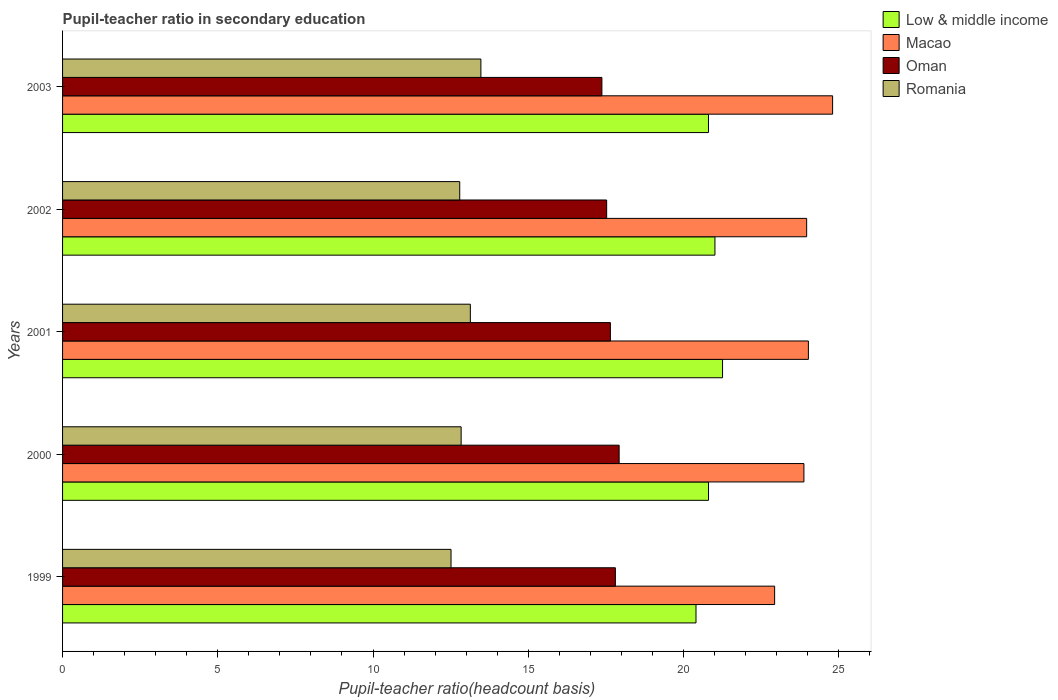How many different coloured bars are there?
Your response must be concise. 4. How many groups of bars are there?
Offer a terse response. 5. Are the number of bars on each tick of the Y-axis equal?
Give a very brief answer. Yes. How many bars are there on the 4th tick from the top?
Make the answer very short. 4. What is the label of the 2nd group of bars from the top?
Provide a short and direct response. 2002. What is the pupil-teacher ratio in secondary education in Romania in 2002?
Your answer should be compact. 12.79. Across all years, what is the maximum pupil-teacher ratio in secondary education in Oman?
Your response must be concise. 17.93. Across all years, what is the minimum pupil-teacher ratio in secondary education in Romania?
Provide a succinct answer. 12.51. In which year was the pupil-teacher ratio in secondary education in Macao minimum?
Make the answer very short. 1999. What is the total pupil-teacher ratio in secondary education in Romania in the graph?
Keep it short and to the point. 64.76. What is the difference between the pupil-teacher ratio in secondary education in Oman in 1999 and that in 2000?
Provide a succinct answer. -0.12. What is the difference between the pupil-teacher ratio in secondary education in Oman in 2001 and the pupil-teacher ratio in secondary education in Low & middle income in 2002?
Keep it short and to the point. -3.37. What is the average pupil-teacher ratio in secondary education in Low & middle income per year?
Provide a short and direct response. 20.86. In the year 2001, what is the difference between the pupil-teacher ratio in secondary education in Oman and pupil-teacher ratio in secondary education in Romania?
Give a very brief answer. 4.51. What is the ratio of the pupil-teacher ratio in secondary education in Romania in 2000 to that in 2001?
Make the answer very short. 0.98. Is the pupil-teacher ratio in secondary education in Oman in 2001 less than that in 2003?
Keep it short and to the point. No. What is the difference between the highest and the second highest pupil-teacher ratio in secondary education in Macao?
Provide a succinct answer. 0.78. What is the difference between the highest and the lowest pupil-teacher ratio in secondary education in Macao?
Offer a very short reply. 1.87. In how many years, is the pupil-teacher ratio in secondary education in Low & middle income greater than the average pupil-teacher ratio in secondary education in Low & middle income taken over all years?
Provide a succinct answer. 2. Is the sum of the pupil-teacher ratio in secondary education in Macao in 1999 and 2002 greater than the maximum pupil-teacher ratio in secondary education in Oman across all years?
Keep it short and to the point. Yes. Is it the case that in every year, the sum of the pupil-teacher ratio in secondary education in Romania and pupil-teacher ratio in secondary education in Oman is greater than the sum of pupil-teacher ratio in secondary education in Low & middle income and pupil-teacher ratio in secondary education in Macao?
Your answer should be compact. Yes. What does the 2nd bar from the bottom in 1999 represents?
Make the answer very short. Macao. Are all the bars in the graph horizontal?
Make the answer very short. Yes. What is the difference between two consecutive major ticks on the X-axis?
Provide a short and direct response. 5. Are the values on the major ticks of X-axis written in scientific E-notation?
Ensure brevity in your answer.  No. How are the legend labels stacked?
Provide a short and direct response. Vertical. What is the title of the graph?
Offer a terse response. Pupil-teacher ratio in secondary education. Does "Luxembourg" appear as one of the legend labels in the graph?
Make the answer very short. No. What is the label or title of the X-axis?
Your response must be concise. Pupil-teacher ratio(headcount basis). What is the label or title of the Y-axis?
Provide a succinct answer. Years. What is the Pupil-teacher ratio(headcount basis) in Low & middle income in 1999?
Ensure brevity in your answer.  20.4. What is the Pupil-teacher ratio(headcount basis) of Macao in 1999?
Ensure brevity in your answer.  22.94. What is the Pupil-teacher ratio(headcount basis) of Oman in 1999?
Your answer should be compact. 17.81. What is the Pupil-teacher ratio(headcount basis) of Romania in 1999?
Offer a terse response. 12.51. What is the Pupil-teacher ratio(headcount basis) in Low & middle income in 2000?
Keep it short and to the point. 20.81. What is the Pupil-teacher ratio(headcount basis) in Macao in 2000?
Your response must be concise. 23.88. What is the Pupil-teacher ratio(headcount basis) in Oman in 2000?
Provide a short and direct response. 17.93. What is the Pupil-teacher ratio(headcount basis) in Romania in 2000?
Provide a succinct answer. 12.84. What is the Pupil-teacher ratio(headcount basis) in Low & middle income in 2001?
Keep it short and to the point. 21.26. What is the Pupil-teacher ratio(headcount basis) of Macao in 2001?
Provide a succinct answer. 24.02. What is the Pupil-teacher ratio(headcount basis) in Oman in 2001?
Give a very brief answer. 17.65. What is the Pupil-teacher ratio(headcount basis) in Romania in 2001?
Your answer should be very brief. 13.14. What is the Pupil-teacher ratio(headcount basis) in Low & middle income in 2002?
Provide a short and direct response. 21.01. What is the Pupil-teacher ratio(headcount basis) in Macao in 2002?
Make the answer very short. 23.97. What is the Pupil-teacher ratio(headcount basis) of Oman in 2002?
Make the answer very short. 17.53. What is the Pupil-teacher ratio(headcount basis) of Romania in 2002?
Provide a succinct answer. 12.79. What is the Pupil-teacher ratio(headcount basis) of Low & middle income in 2003?
Your answer should be compact. 20.81. What is the Pupil-teacher ratio(headcount basis) of Macao in 2003?
Ensure brevity in your answer.  24.8. What is the Pupil-teacher ratio(headcount basis) of Oman in 2003?
Your answer should be very brief. 17.37. What is the Pupil-teacher ratio(headcount basis) in Romania in 2003?
Make the answer very short. 13.47. Across all years, what is the maximum Pupil-teacher ratio(headcount basis) of Low & middle income?
Offer a very short reply. 21.26. Across all years, what is the maximum Pupil-teacher ratio(headcount basis) of Macao?
Provide a succinct answer. 24.8. Across all years, what is the maximum Pupil-teacher ratio(headcount basis) in Oman?
Ensure brevity in your answer.  17.93. Across all years, what is the maximum Pupil-teacher ratio(headcount basis) of Romania?
Make the answer very short. 13.47. Across all years, what is the minimum Pupil-teacher ratio(headcount basis) of Low & middle income?
Provide a short and direct response. 20.4. Across all years, what is the minimum Pupil-teacher ratio(headcount basis) in Macao?
Offer a terse response. 22.94. Across all years, what is the minimum Pupil-teacher ratio(headcount basis) of Oman?
Provide a short and direct response. 17.37. Across all years, what is the minimum Pupil-teacher ratio(headcount basis) in Romania?
Offer a very short reply. 12.51. What is the total Pupil-teacher ratio(headcount basis) in Low & middle income in the graph?
Offer a very short reply. 104.29. What is the total Pupil-teacher ratio(headcount basis) of Macao in the graph?
Provide a short and direct response. 119.61. What is the total Pupil-teacher ratio(headcount basis) of Oman in the graph?
Offer a very short reply. 88.28. What is the total Pupil-teacher ratio(headcount basis) of Romania in the graph?
Your answer should be very brief. 64.76. What is the difference between the Pupil-teacher ratio(headcount basis) in Low & middle income in 1999 and that in 2000?
Offer a very short reply. -0.4. What is the difference between the Pupil-teacher ratio(headcount basis) in Macao in 1999 and that in 2000?
Your answer should be very brief. -0.94. What is the difference between the Pupil-teacher ratio(headcount basis) in Oman in 1999 and that in 2000?
Provide a succinct answer. -0.12. What is the difference between the Pupil-teacher ratio(headcount basis) of Romania in 1999 and that in 2000?
Provide a short and direct response. -0.33. What is the difference between the Pupil-teacher ratio(headcount basis) of Low & middle income in 1999 and that in 2001?
Your answer should be compact. -0.85. What is the difference between the Pupil-teacher ratio(headcount basis) of Macao in 1999 and that in 2001?
Your answer should be very brief. -1.09. What is the difference between the Pupil-teacher ratio(headcount basis) of Oman in 1999 and that in 2001?
Keep it short and to the point. 0.16. What is the difference between the Pupil-teacher ratio(headcount basis) in Romania in 1999 and that in 2001?
Your response must be concise. -0.62. What is the difference between the Pupil-teacher ratio(headcount basis) of Low & middle income in 1999 and that in 2002?
Provide a succinct answer. -0.61. What is the difference between the Pupil-teacher ratio(headcount basis) in Macao in 1999 and that in 2002?
Your answer should be very brief. -1.03. What is the difference between the Pupil-teacher ratio(headcount basis) in Oman in 1999 and that in 2002?
Give a very brief answer. 0.28. What is the difference between the Pupil-teacher ratio(headcount basis) of Romania in 1999 and that in 2002?
Provide a succinct answer. -0.28. What is the difference between the Pupil-teacher ratio(headcount basis) in Low & middle income in 1999 and that in 2003?
Your answer should be compact. -0.4. What is the difference between the Pupil-teacher ratio(headcount basis) in Macao in 1999 and that in 2003?
Offer a very short reply. -1.87. What is the difference between the Pupil-teacher ratio(headcount basis) in Oman in 1999 and that in 2003?
Provide a short and direct response. 0.43. What is the difference between the Pupil-teacher ratio(headcount basis) of Romania in 1999 and that in 2003?
Your response must be concise. -0.96. What is the difference between the Pupil-teacher ratio(headcount basis) of Low & middle income in 2000 and that in 2001?
Provide a succinct answer. -0.45. What is the difference between the Pupil-teacher ratio(headcount basis) in Macao in 2000 and that in 2001?
Make the answer very short. -0.14. What is the difference between the Pupil-teacher ratio(headcount basis) in Oman in 2000 and that in 2001?
Give a very brief answer. 0.28. What is the difference between the Pupil-teacher ratio(headcount basis) of Romania in 2000 and that in 2001?
Your response must be concise. -0.3. What is the difference between the Pupil-teacher ratio(headcount basis) in Low & middle income in 2000 and that in 2002?
Your answer should be compact. -0.21. What is the difference between the Pupil-teacher ratio(headcount basis) in Macao in 2000 and that in 2002?
Provide a succinct answer. -0.09. What is the difference between the Pupil-teacher ratio(headcount basis) of Oman in 2000 and that in 2002?
Ensure brevity in your answer.  0.4. What is the difference between the Pupil-teacher ratio(headcount basis) of Romania in 2000 and that in 2002?
Your answer should be compact. 0.04. What is the difference between the Pupil-teacher ratio(headcount basis) in Low & middle income in 2000 and that in 2003?
Provide a succinct answer. 0. What is the difference between the Pupil-teacher ratio(headcount basis) in Macao in 2000 and that in 2003?
Provide a succinct answer. -0.92. What is the difference between the Pupil-teacher ratio(headcount basis) in Oman in 2000 and that in 2003?
Your answer should be compact. 0.56. What is the difference between the Pupil-teacher ratio(headcount basis) in Romania in 2000 and that in 2003?
Make the answer very short. -0.64. What is the difference between the Pupil-teacher ratio(headcount basis) of Low & middle income in 2001 and that in 2002?
Ensure brevity in your answer.  0.25. What is the difference between the Pupil-teacher ratio(headcount basis) in Macao in 2001 and that in 2002?
Make the answer very short. 0.06. What is the difference between the Pupil-teacher ratio(headcount basis) of Oman in 2001 and that in 2002?
Keep it short and to the point. 0.12. What is the difference between the Pupil-teacher ratio(headcount basis) of Romania in 2001 and that in 2002?
Offer a very short reply. 0.34. What is the difference between the Pupil-teacher ratio(headcount basis) in Low & middle income in 2001 and that in 2003?
Offer a terse response. 0.45. What is the difference between the Pupil-teacher ratio(headcount basis) in Macao in 2001 and that in 2003?
Your answer should be very brief. -0.78. What is the difference between the Pupil-teacher ratio(headcount basis) in Oman in 2001 and that in 2003?
Provide a short and direct response. 0.27. What is the difference between the Pupil-teacher ratio(headcount basis) of Romania in 2001 and that in 2003?
Offer a very short reply. -0.34. What is the difference between the Pupil-teacher ratio(headcount basis) of Low & middle income in 2002 and that in 2003?
Keep it short and to the point. 0.21. What is the difference between the Pupil-teacher ratio(headcount basis) of Macao in 2002 and that in 2003?
Your response must be concise. -0.84. What is the difference between the Pupil-teacher ratio(headcount basis) of Oman in 2002 and that in 2003?
Keep it short and to the point. 0.15. What is the difference between the Pupil-teacher ratio(headcount basis) of Romania in 2002 and that in 2003?
Provide a succinct answer. -0.68. What is the difference between the Pupil-teacher ratio(headcount basis) of Low & middle income in 1999 and the Pupil-teacher ratio(headcount basis) of Macao in 2000?
Offer a terse response. -3.48. What is the difference between the Pupil-teacher ratio(headcount basis) in Low & middle income in 1999 and the Pupil-teacher ratio(headcount basis) in Oman in 2000?
Offer a terse response. 2.48. What is the difference between the Pupil-teacher ratio(headcount basis) in Low & middle income in 1999 and the Pupil-teacher ratio(headcount basis) in Romania in 2000?
Ensure brevity in your answer.  7.57. What is the difference between the Pupil-teacher ratio(headcount basis) in Macao in 1999 and the Pupil-teacher ratio(headcount basis) in Oman in 2000?
Make the answer very short. 5.01. What is the difference between the Pupil-teacher ratio(headcount basis) in Macao in 1999 and the Pupil-teacher ratio(headcount basis) in Romania in 2000?
Offer a very short reply. 10.1. What is the difference between the Pupil-teacher ratio(headcount basis) of Oman in 1999 and the Pupil-teacher ratio(headcount basis) of Romania in 2000?
Ensure brevity in your answer.  4.97. What is the difference between the Pupil-teacher ratio(headcount basis) in Low & middle income in 1999 and the Pupil-teacher ratio(headcount basis) in Macao in 2001?
Provide a succinct answer. -3.62. What is the difference between the Pupil-teacher ratio(headcount basis) in Low & middle income in 1999 and the Pupil-teacher ratio(headcount basis) in Oman in 2001?
Your answer should be compact. 2.76. What is the difference between the Pupil-teacher ratio(headcount basis) in Low & middle income in 1999 and the Pupil-teacher ratio(headcount basis) in Romania in 2001?
Your answer should be compact. 7.27. What is the difference between the Pupil-teacher ratio(headcount basis) in Macao in 1999 and the Pupil-teacher ratio(headcount basis) in Oman in 2001?
Your answer should be very brief. 5.29. What is the difference between the Pupil-teacher ratio(headcount basis) in Macao in 1999 and the Pupil-teacher ratio(headcount basis) in Romania in 2001?
Your response must be concise. 9.8. What is the difference between the Pupil-teacher ratio(headcount basis) of Oman in 1999 and the Pupil-teacher ratio(headcount basis) of Romania in 2001?
Offer a very short reply. 4.67. What is the difference between the Pupil-teacher ratio(headcount basis) in Low & middle income in 1999 and the Pupil-teacher ratio(headcount basis) in Macao in 2002?
Your answer should be compact. -3.56. What is the difference between the Pupil-teacher ratio(headcount basis) in Low & middle income in 1999 and the Pupil-teacher ratio(headcount basis) in Oman in 2002?
Your answer should be very brief. 2.88. What is the difference between the Pupil-teacher ratio(headcount basis) of Low & middle income in 1999 and the Pupil-teacher ratio(headcount basis) of Romania in 2002?
Provide a short and direct response. 7.61. What is the difference between the Pupil-teacher ratio(headcount basis) of Macao in 1999 and the Pupil-teacher ratio(headcount basis) of Oman in 2002?
Offer a terse response. 5.41. What is the difference between the Pupil-teacher ratio(headcount basis) in Macao in 1999 and the Pupil-teacher ratio(headcount basis) in Romania in 2002?
Your answer should be compact. 10.14. What is the difference between the Pupil-teacher ratio(headcount basis) in Oman in 1999 and the Pupil-teacher ratio(headcount basis) in Romania in 2002?
Give a very brief answer. 5.01. What is the difference between the Pupil-teacher ratio(headcount basis) in Low & middle income in 1999 and the Pupil-teacher ratio(headcount basis) in Macao in 2003?
Make the answer very short. -4.4. What is the difference between the Pupil-teacher ratio(headcount basis) in Low & middle income in 1999 and the Pupil-teacher ratio(headcount basis) in Oman in 2003?
Make the answer very short. 3.03. What is the difference between the Pupil-teacher ratio(headcount basis) in Low & middle income in 1999 and the Pupil-teacher ratio(headcount basis) in Romania in 2003?
Your response must be concise. 6.93. What is the difference between the Pupil-teacher ratio(headcount basis) of Macao in 1999 and the Pupil-teacher ratio(headcount basis) of Oman in 2003?
Give a very brief answer. 5.56. What is the difference between the Pupil-teacher ratio(headcount basis) in Macao in 1999 and the Pupil-teacher ratio(headcount basis) in Romania in 2003?
Give a very brief answer. 9.46. What is the difference between the Pupil-teacher ratio(headcount basis) in Oman in 1999 and the Pupil-teacher ratio(headcount basis) in Romania in 2003?
Give a very brief answer. 4.33. What is the difference between the Pupil-teacher ratio(headcount basis) of Low & middle income in 2000 and the Pupil-teacher ratio(headcount basis) of Macao in 2001?
Provide a succinct answer. -3.22. What is the difference between the Pupil-teacher ratio(headcount basis) of Low & middle income in 2000 and the Pupil-teacher ratio(headcount basis) of Oman in 2001?
Your answer should be compact. 3.16. What is the difference between the Pupil-teacher ratio(headcount basis) of Low & middle income in 2000 and the Pupil-teacher ratio(headcount basis) of Romania in 2001?
Ensure brevity in your answer.  7.67. What is the difference between the Pupil-teacher ratio(headcount basis) of Macao in 2000 and the Pupil-teacher ratio(headcount basis) of Oman in 2001?
Your answer should be compact. 6.23. What is the difference between the Pupil-teacher ratio(headcount basis) in Macao in 2000 and the Pupil-teacher ratio(headcount basis) in Romania in 2001?
Provide a short and direct response. 10.75. What is the difference between the Pupil-teacher ratio(headcount basis) in Oman in 2000 and the Pupil-teacher ratio(headcount basis) in Romania in 2001?
Your answer should be very brief. 4.79. What is the difference between the Pupil-teacher ratio(headcount basis) in Low & middle income in 2000 and the Pupil-teacher ratio(headcount basis) in Macao in 2002?
Provide a short and direct response. -3.16. What is the difference between the Pupil-teacher ratio(headcount basis) in Low & middle income in 2000 and the Pupil-teacher ratio(headcount basis) in Oman in 2002?
Provide a short and direct response. 3.28. What is the difference between the Pupil-teacher ratio(headcount basis) of Low & middle income in 2000 and the Pupil-teacher ratio(headcount basis) of Romania in 2002?
Your answer should be compact. 8.01. What is the difference between the Pupil-teacher ratio(headcount basis) in Macao in 2000 and the Pupil-teacher ratio(headcount basis) in Oman in 2002?
Offer a terse response. 6.35. What is the difference between the Pupil-teacher ratio(headcount basis) of Macao in 2000 and the Pupil-teacher ratio(headcount basis) of Romania in 2002?
Make the answer very short. 11.09. What is the difference between the Pupil-teacher ratio(headcount basis) of Oman in 2000 and the Pupil-teacher ratio(headcount basis) of Romania in 2002?
Your response must be concise. 5.13. What is the difference between the Pupil-teacher ratio(headcount basis) of Low & middle income in 2000 and the Pupil-teacher ratio(headcount basis) of Macao in 2003?
Provide a succinct answer. -4. What is the difference between the Pupil-teacher ratio(headcount basis) in Low & middle income in 2000 and the Pupil-teacher ratio(headcount basis) in Oman in 2003?
Ensure brevity in your answer.  3.43. What is the difference between the Pupil-teacher ratio(headcount basis) in Low & middle income in 2000 and the Pupil-teacher ratio(headcount basis) in Romania in 2003?
Your response must be concise. 7.33. What is the difference between the Pupil-teacher ratio(headcount basis) of Macao in 2000 and the Pupil-teacher ratio(headcount basis) of Oman in 2003?
Provide a short and direct response. 6.51. What is the difference between the Pupil-teacher ratio(headcount basis) of Macao in 2000 and the Pupil-teacher ratio(headcount basis) of Romania in 2003?
Ensure brevity in your answer.  10.41. What is the difference between the Pupil-teacher ratio(headcount basis) of Oman in 2000 and the Pupil-teacher ratio(headcount basis) of Romania in 2003?
Make the answer very short. 4.45. What is the difference between the Pupil-teacher ratio(headcount basis) of Low & middle income in 2001 and the Pupil-teacher ratio(headcount basis) of Macao in 2002?
Your answer should be very brief. -2.71. What is the difference between the Pupil-teacher ratio(headcount basis) in Low & middle income in 2001 and the Pupil-teacher ratio(headcount basis) in Oman in 2002?
Your answer should be compact. 3.73. What is the difference between the Pupil-teacher ratio(headcount basis) in Low & middle income in 2001 and the Pupil-teacher ratio(headcount basis) in Romania in 2002?
Your answer should be very brief. 8.47. What is the difference between the Pupil-teacher ratio(headcount basis) of Macao in 2001 and the Pupil-teacher ratio(headcount basis) of Oman in 2002?
Your response must be concise. 6.5. What is the difference between the Pupil-teacher ratio(headcount basis) of Macao in 2001 and the Pupil-teacher ratio(headcount basis) of Romania in 2002?
Ensure brevity in your answer.  11.23. What is the difference between the Pupil-teacher ratio(headcount basis) of Oman in 2001 and the Pupil-teacher ratio(headcount basis) of Romania in 2002?
Provide a short and direct response. 4.85. What is the difference between the Pupil-teacher ratio(headcount basis) of Low & middle income in 2001 and the Pupil-teacher ratio(headcount basis) of Macao in 2003?
Offer a terse response. -3.55. What is the difference between the Pupil-teacher ratio(headcount basis) in Low & middle income in 2001 and the Pupil-teacher ratio(headcount basis) in Oman in 2003?
Provide a succinct answer. 3.89. What is the difference between the Pupil-teacher ratio(headcount basis) of Low & middle income in 2001 and the Pupil-teacher ratio(headcount basis) of Romania in 2003?
Your response must be concise. 7.78. What is the difference between the Pupil-teacher ratio(headcount basis) of Macao in 2001 and the Pupil-teacher ratio(headcount basis) of Oman in 2003?
Give a very brief answer. 6.65. What is the difference between the Pupil-teacher ratio(headcount basis) of Macao in 2001 and the Pupil-teacher ratio(headcount basis) of Romania in 2003?
Keep it short and to the point. 10.55. What is the difference between the Pupil-teacher ratio(headcount basis) in Oman in 2001 and the Pupil-teacher ratio(headcount basis) in Romania in 2003?
Your answer should be compact. 4.17. What is the difference between the Pupil-teacher ratio(headcount basis) of Low & middle income in 2002 and the Pupil-teacher ratio(headcount basis) of Macao in 2003?
Provide a succinct answer. -3.79. What is the difference between the Pupil-teacher ratio(headcount basis) in Low & middle income in 2002 and the Pupil-teacher ratio(headcount basis) in Oman in 2003?
Your answer should be very brief. 3.64. What is the difference between the Pupil-teacher ratio(headcount basis) in Low & middle income in 2002 and the Pupil-teacher ratio(headcount basis) in Romania in 2003?
Ensure brevity in your answer.  7.54. What is the difference between the Pupil-teacher ratio(headcount basis) in Macao in 2002 and the Pupil-teacher ratio(headcount basis) in Oman in 2003?
Your answer should be compact. 6.6. What is the difference between the Pupil-teacher ratio(headcount basis) in Macao in 2002 and the Pupil-teacher ratio(headcount basis) in Romania in 2003?
Make the answer very short. 10.49. What is the difference between the Pupil-teacher ratio(headcount basis) in Oman in 2002 and the Pupil-teacher ratio(headcount basis) in Romania in 2003?
Your response must be concise. 4.05. What is the average Pupil-teacher ratio(headcount basis) of Low & middle income per year?
Provide a short and direct response. 20.86. What is the average Pupil-teacher ratio(headcount basis) of Macao per year?
Your response must be concise. 23.92. What is the average Pupil-teacher ratio(headcount basis) of Oman per year?
Offer a very short reply. 17.66. What is the average Pupil-teacher ratio(headcount basis) in Romania per year?
Make the answer very short. 12.95. In the year 1999, what is the difference between the Pupil-teacher ratio(headcount basis) of Low & middle income and Pupil-teacher ratio(headcount basis) of Macao?
Keep it short and to the point. -2.53. In the year 1999, what is the difference between the Pupil-teacher ratio(headcount basis) of Low & middle income and Pupil-teacher ratio(headcount basis) of Oman?
Your answer should be very brief. 2.6. In the year 1999, what is the difference between the Pupil-teacher ratio(headcount basis) in Low & middle income and Pupil-teacher ratio(headcount basis) in Romania?
Provide a succinct answer. 7.89. In the year 1999, what is the difference between the Pupil-teacher ratio(headcount basis) of Macao and Pupil-teacher ratio(headcount basis) of Oman?
Provide a succinct answer. 5.13. In the year 1999, what is the difference between the Pupil-teacher ratio(headcount basis) of Macao and Pupil-teacher ratio(headcount basis) of Romania?
Your answer should be very brief. 10.42. In the year 1999, what is the difference between the Pupil-teacher ratio(headcount basis) of Oman and Pupil-teacher ratio(headcount basis) of Romania?
Provide a short and direct response. 5.29. In the year 2000, what is the difference between the Pupil-teacher ratio(headcount basis) in Low & middle income and Pupil-teacher ratio(headcount basis) in Macao?
Give a very brief answer. -3.07. In the year 2000, what is the difference between the Pupil-teacher ratio(headcount basis) in Low & middle income and Pupil-teacher ratio(headcount basis) in Oman?
Make the answer very short. 2.88. In the year 2000, what is the difference between the Pupil-teacher ratio(headcount basis) of Low & middle income and Pupil-teacher ratio(headcount basis) of Romania?
Offer a very short reply. 7.97. In the year 2000, what is the difference between the Pupil-teacher ratio(headcount basis) in Macao and Pupil-teacher ratio(headcount basis) in Oman?
Keep it short and to the point. 5.95. In the year 2000, what is the difference between the Pupil-teacher ratio(headcount basis) in Macao and Pupil-teacher ratio(headcount basis) in Romania?
Keep it short and to the point. 11.04. In the year 2000, what is the difference between the Pupil-teacher ratio(headcount basis) in Oman and Pupil-teacher ratio(headcount basis) in Romania?
Provide a succinct answer. 5.09. In the year 2001, what is the difference between the Pupil-teacher ratio(headcount basis) of Low & middle income and Pupil-teacher ratio(headcount basis) of Macao?
Give a very brief answer. -2.77. In the year 2001, what is the difference between the Pupil-teacher ratio(headcount basis) in Low & middle income and Pupil-teacher ratio(headcount basis) in Oman?
Your response must be concise. 3.61. In the year 2001, what is the difference between the Pupil-teacher ratio(headcount basis) of Low & middle income and Pupil-teacher ratio(headcount basis) of Romania?
Ensure brevity in your answer.  8.12. In the year 2001, what is the difference between the Pupil-teacher ratio(headcount basis) in Macao and Pupil-teacher ratio(headcount basis) in Oman?
Offer a terse response. 6.38. In the year 2001, what is the difference between the Pupil-teacher ratio(headcount basis) of Macao and Pupil-teacher ratio(headcount basis) of Romania?
Provide a short and direct response. 10.89. In the year 2001, what is the difference between the Pupil-teacher ratio(headcount basis) of Oman and Pupil-teacher ratio(headcount basis) of Romania?
Make the answer very short. 4.51. In the year 2002, what is the difference between the Pupil-teacher ratio(headcount basis) of Low & middle income and Pupil-teacher ratio(headcount basis) of Macao?
Make the answer very short. -2.95. In the year 2002, what is the difference between the Pupil-teacher ratio(headcount basis) of Low & middle income and Pupil-teacher ratio(headcount basis) of Oman?
Provide a short and direct response. 3.49. In the year 2002, what is the difference between the Pupil-teacher ratio(headcount basis) of Low & middle income and Pupil-teacher ratio(headcount basis) of Romania?
Provide a short and direct response. 8.22. In the year 2002, what is the difference between the Pupil-teacher ratio(headcount basis) in Macao and Pupil-teacher ratio(headcount basis) in Oman?
Provide a succinct answer. 6.44. In the year 2002, what is the difference between the Pupil-teacher ratio(headcount basis) of Macao and Pupil-teacher ratio(headcount basis) of Romania?
Ensure brevity in your answer.  11.17. In the year 2002, what is the difference between the Pupil-teacher ratio(headcount basis) of Oman and Pupil-teacher ratio(headcount basis) of Romania?
Your answer should be compact. 4.73. In the year 2003, what is the difference between the Pupil-teacher ratio(headcount basis) in Low & middle income and Pupil-teacher ratio(headcount basis) in Macao?
Ensure brevity in your answer.  -4. In the year 2003, what is the difference between the Pupil-teacher ratio(headcount basis) in Low & middle income and Pupil-teacher ratio(headcount basis) in Oman?
Make the answer very short. 3.43. In the year 2003, what is the difference between the Pupil-teacher ratio(headcount basis) in Low & middle income and Pupil-teacher ratio(headcount basis) in Romania?
Give a very brief answer. 7.33. In the year 2003, what is the difference between the Pupil-teacher ratio(headcount basis) of Macao and Pupil-teacher ratio(headcount basis) of Oman?
Make the answer very short. 7.43. In the year 2003, what is the difference between the Pupil-teacher ratio(headcount basis) of Macao and Pupil-teacher ratio(headcount basis) of Romania?
Ensure brevity in your answer.  11.33. In the year 2003, what is the difference between the Pupil-teacher ratio(headcount basis) of Oman and Pupil-teacher ratio(headcount basis) of Romania?
Offer a very short reply. 3.9. What is the ratio of the Pupil-teacher ratio(headcount basis) in Low & middle income in 1999 to that in 2000?
Make the answer very short. 0.98. What is the ratio of the Pupil-teacher ratio(headcount basis) in Macao in 1999 to that in 2000?
Make the answer very short. 0.96. What is the ratio of the Pupil-teacher ratio(headcount basis) in Oman in 1999 to that in 2000?
Provide a short and direct response. 0.99. What is the ratio of the Pupil-teacher ratio(headcount basis) of Romania in 1999 to that in 2000?
Your answer should be compact. 0.97. What is the ratio of the Pupil-teacher ratio(headcount basis) of Low & middle income in 1999 to that in 2001?
Offer a very short reply. 0.96. What is the ratio of the Pupil-teacher ratio(headcount basis) in Macao in 1999 to that in 2001?
Your response must be concise. 0.95. What is the ratio of the Pupil-teacher ratio(headcount basis) of Oman in 1999 to that in 2001?
Provide a short and direct response. 1.01. What is the ratio of the Pupil-teacher ratio(headcount basis) in Romania in 1999 to that in 2001?
Provide a succinct answer. 0.95. What is the ratio of the Pupil-teacher ratio(headcount basis) in Low & middle income in 1999 to that in 2002?
Give a very brief answer. 0.97. What is the ratio of the Pupil-teacher ratio(headcount basis) of Macao in 1999 to that in 2002?
Offer a very short reply. 0.96. What is the ratio of the Pupil-teacher ratio(headcount basis) in Romania in 1999 to that in 2002?
Ensure brevity in your answer.  0.98. What is the ratio of the Pupil-teacher ratio(headcount basis) of Low & middle income in 1999 to that in 2003?
Your response must be concise. 0.98. What is the ratio of the Pupil-teacher ratio(headcount basis) of Macao in 1999 to that in 2003?
Keep it short and to the point. 0.92. What is the ratio of the Pupil-teacher ratio(headcount basis) of Oman in 1999 to that in 2003?
Provide a short and direct response. 1.02. What is the ratio of the Pupil-teacher ratio(headcount basis) of Romania in 1999 to that in 2003?
Make the answer very short. 0.93. What is the ratio of the Pupil-teacher ratio(headcount basis) of Low & middle income in 2000 to that in 2001?
Give a very brief answer. 0.98. What is the ratio of the Pupil-teacher ratio(headcount basis) of Macao in 2000 to that in 2001?
Provide a succinct answer. 0.99. What is the ratio of the Pupil-teacher ratio(headcount basis) in Oman in 2000 to that in 2001?
Your answer should be compact. 1.02. What is the ratio of the Pupil-teacher ratio(headcount basis) of Romania in 2000 to that in 2001?
Your answer should be very brief. 0.98. What is the ratio of the Pupil-teacher ratio(headcount basis) of Low & middle income in 2000 to that in 2002?
Offer a terse response. 0.99. What is the ratio of the Pupil-teacher ratio(headcount basis) in Oman in 2000 to that in 2002?
Keep it short and to the point. 1.02. What is the ratio of the Pupil-teacher ratio(headcount basis) in Romania in 2000 to that in 2002?
Ensure brevity in your answer.  1. What is the ratio of the Pupil-teacher ratio(headcount basis) of Low & middle income in 2000 to that in 2003?
Give a very brief answer. 1. What is the ratio of the Pupil-teacher ratio(headcount basis) in Macao in 2000 to that in 2003?
Ensure brevity in your answer.  0.96. What is the ratio of the Pupil-teacher ratio(headcount basis) in Oman in 2000 to that in 2003?
Ensure brevity in your answer.  1.03. What is the ratio of the Pupil-teacher ratio(headcount basis) in Romania in 2000 to that in 2003?
Your answer should be very brief. 0.95. What is the ratio of the Pupil-teacher ratio(headcount basis) of Low & middle income in 2001 to that in 2002?
Offer a terse response. 1.01. What is the ratio of the Pupil-teacher ratio(headcount basis) of Romania in 2001 to that in 2002?
Give a very brief answer. 1.03. What is the ratio of the Pupil-teacher ratio(headcount basis) in Low & middle income in 2001 to that in 2003?
Offer a terse response. 1.02. What is the ratio of the Pupil-teacher ratio(headcount basis) of Macao in 2001 to that in 2003?
Offer a very short reply. 0.97. What is the ratio of the Pupil-teacher ratio(headcount basis) in Oman in 2001 to that in 2003?
Offer a very short reply. 1.02. What is the ratio of the Pupil-teacher ratio(headcount basis) in Romania in 2001 to that in 2003?
Your response must be concise. 0.97. What is the ratio of the Pupil-teacher ratio(headcount basis) in Low & middle income in 2002 to that in 2003?
Offer a terse response. 1.01. What is the ratio of the Pupil-teacher ratio(headcount basis) of Macao in 2002 to that in 2003?
Your answer should be compact. 0.97. What is the ratio of the Pupil-teacher ratio(headcount basis) of Oman in 2002 to that in 2003?
Ensure brevity in your answer.  1.01. What is the ratio of the Pupil-teacher ratio(headcount basis) in Romania in 2002 to that in 2003?
Your answer should be compact. 0.95. What is the difference between the highest and the second highest Pupil-teacher ratio(headcount basis) in Low & middle income?
Provide a short and direct response. 0.25. What is the difference between the highest and the second highest Pupil-teacher ratio(headcount basis) in Macao?
Ensure brevity in your answer.  0.78. What is the difference between the highest and the second highest Pupil-teacher ratio(headcount basis) of Oman?
Your answer should be very brief. 0.12. What is the difference between the highest and the second highest Pupil-teacher ratio(headcount basis) in Romania?
Offer a very short reply. 0.34. What is the difference between the highest and the lowest Pupil-teacher ratio(headcount basis) of Low & middle income?
Your response must be concise. 0.85. What is the difference between the highest and the lowest Pupil-teacher ratio(headcount basis) of Macao?
Make the answer very short. 1.87. What is the difference between the highest and the lowest Pupil-teacher ratio(headcount basis) of Oman?
Provide a succinct answer. 0.56. What is the difference between the highest and the lowest Pupil-teacher ratio(headcount basis) of Romania?
Give a very brief answer. 0.96. 